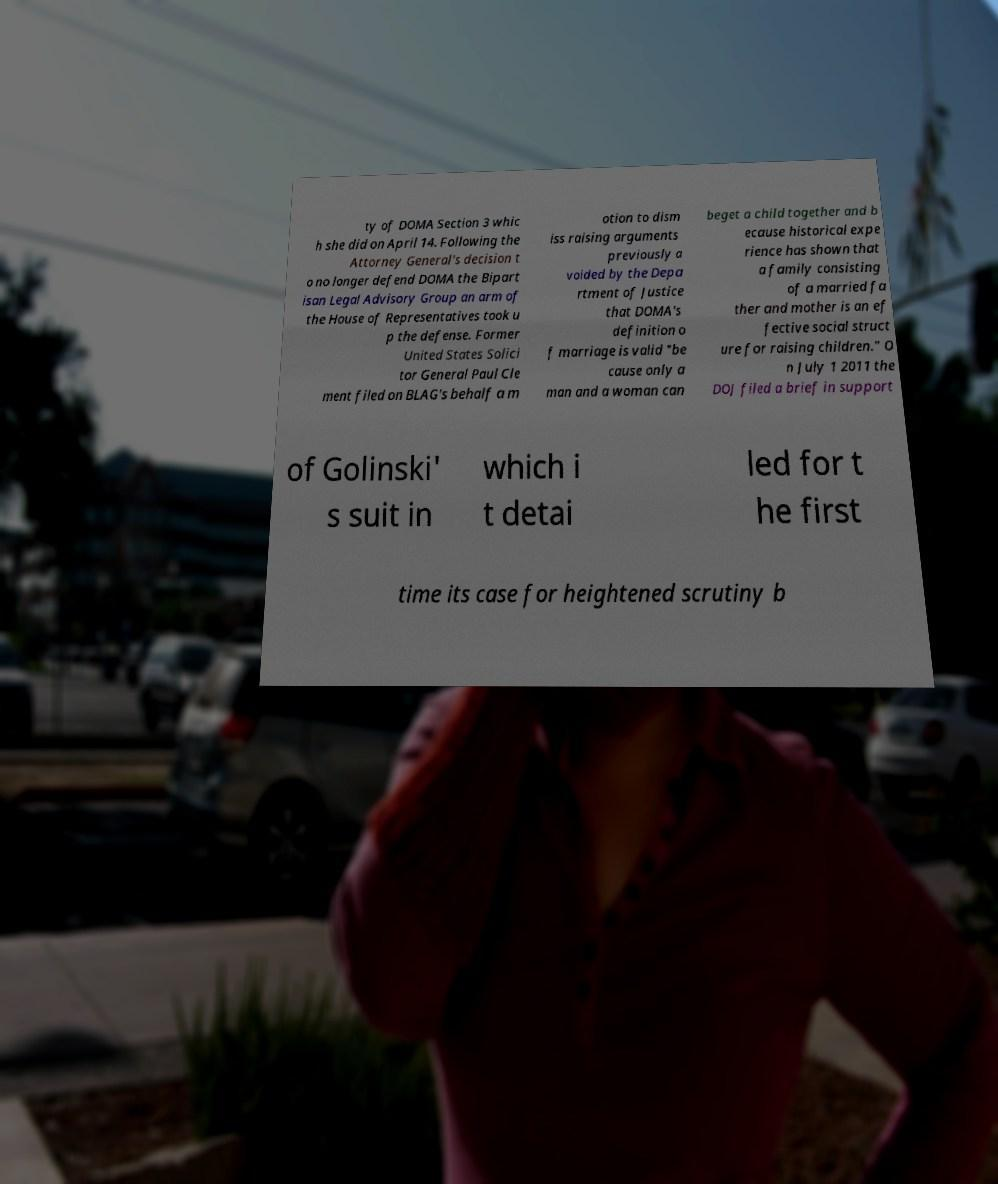There's text embedded in this image that I need extracted. Can you transcribe it verbatim? ty of DOMA Section 3 whic h she did on April 14. Following the Attorney General's decision t o no longer defend DOMA the Bipart isan Legal Advisory Group an arm of the House of Representatives took u p the defense. Former United States Solici tor General Paul Cle ment filed on BLAG's behalf a m otion to dism iss raising arguments previously a voided by the Depa rtment of Justice that DOMA's definition o f marriage is valid "be cause only a man and a woman can beget a child together and b ecause historical expe rience has shown that a family consisting of a married fa ther and mother is an ef fective social struct ure for raising children." O n July 1 2011 the DOJ filed a brief in support of Golinski' s suit in which i t detai led for t he first time its case for heightened scrutiny b 